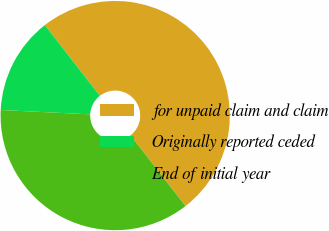Convert chart. <chart><loc_0><loc_0><loc_500><loc_500><pie_chart><fcel>for unpaid claim and claim<fcel>Originally reported ceded<fcel>End of initial year<nl><fcel>50.0%<fcel>13.71%<fcel>36.29%<nl></chart> 